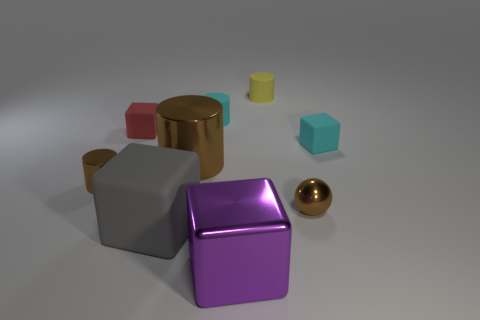Subtract all green cylinders. Subtract all yellow spheres. How many cylinders are left? 4 Add 1 gray cubes. How many objects exist? 10 Subtract all cylinders. How many objects are left? 5 Subtract all small metal balls. Subtract all big cyan rubber cylinders. How many objects are left? 8 Add 5 big gray cubes. How many big gray cubes are left? 6 Add 9 red rubber blocks. How many red rubber blocks exist? 10 Subtract 0 red cylinders. How many objects are left? 9 